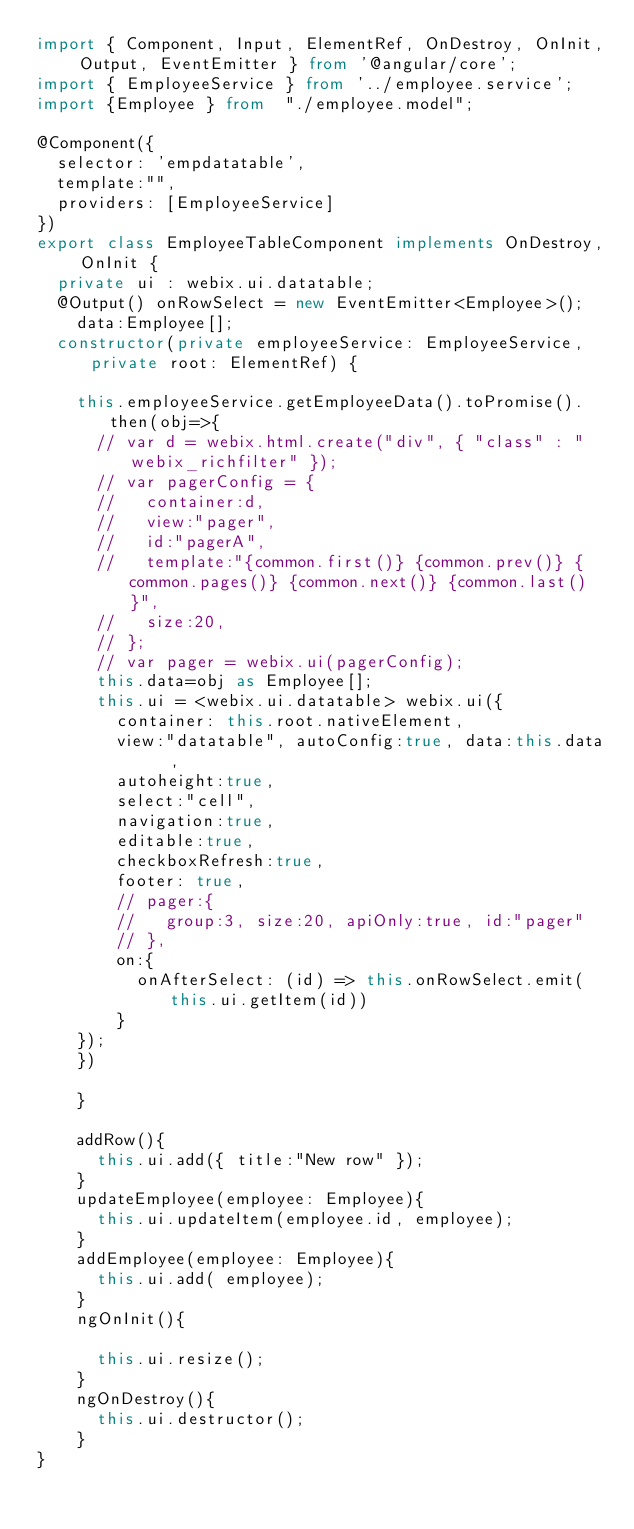Convert code to text. <code><loc_0><loc_0><loc_500><loc_500><_TypeScript_>import { Component, Input, ElementRef, OnDestroy, OnInit, Output, EventEmitter } from '@angular/core';
import { EmployeeService } from '../employee.service';
import {Employee } from  "./employee.model";

@Component({
  selector: 'empdatatable',
  template:"",
  providers: [EmployeeService]
})
export class EmployeeTableComponent implements OnDestroy, OnInit {
  private ui : webix.ui.datatable;
  @Output() onRowSelect = new EventEmitter<Employee>();
    data:Employee[];
  constructor(private employeeService: EmployeeService,private root: ElementRef) {

    this.employeeService.getEmployeeData().toPromise().then(obj=>{
      // var d = webix.html.create("div", { "class" : "webix_richfilter" });
      // var pagerConfig = { 
      //   container:d,
      //   view:"pager",
      //   id:"pagerA",
      //   template:"{common.first()} {common.prev()} {common.pages()} {common.next()} {common.last()}",
      //   size:20, 
      // };
      // var pager = webix.ui(pagerConfig);
      this.data=obj as Employee[];
      this.ui = <webix.ui.datatable> webix.ui({
        container: this.root.nativeElement,
        view:"datatable", autoConfig:true, data:this.data  ,
        autoheight:true,
        select:"cell",
        navigation:true, 
        editable:true,
        checkboxRefresh:true,
        footer: true,
        // pager:{
        //   group:3, size:20, apiOnly:true, id:"pager"
        // },
        on:{
          onAfterSelect: (id) => this.onRowSelect.emit(this.ui.getItem(id))
        }
    });
    })
  
    }
    
    addRow(){
      this.ui.add({ title:"New row" });
    }
    updateEmployee(employee: Employee){
      this.ui.updateItem(employee.id, employee);
    }
    addEmployee(employee: Employee){
      this.ui.add( employee);
    }
    ngOnInit(){
 
      this.ui.resize();
    }
    ngOnDestroy(){
      this.ui.destructor();
    }
}</code> 